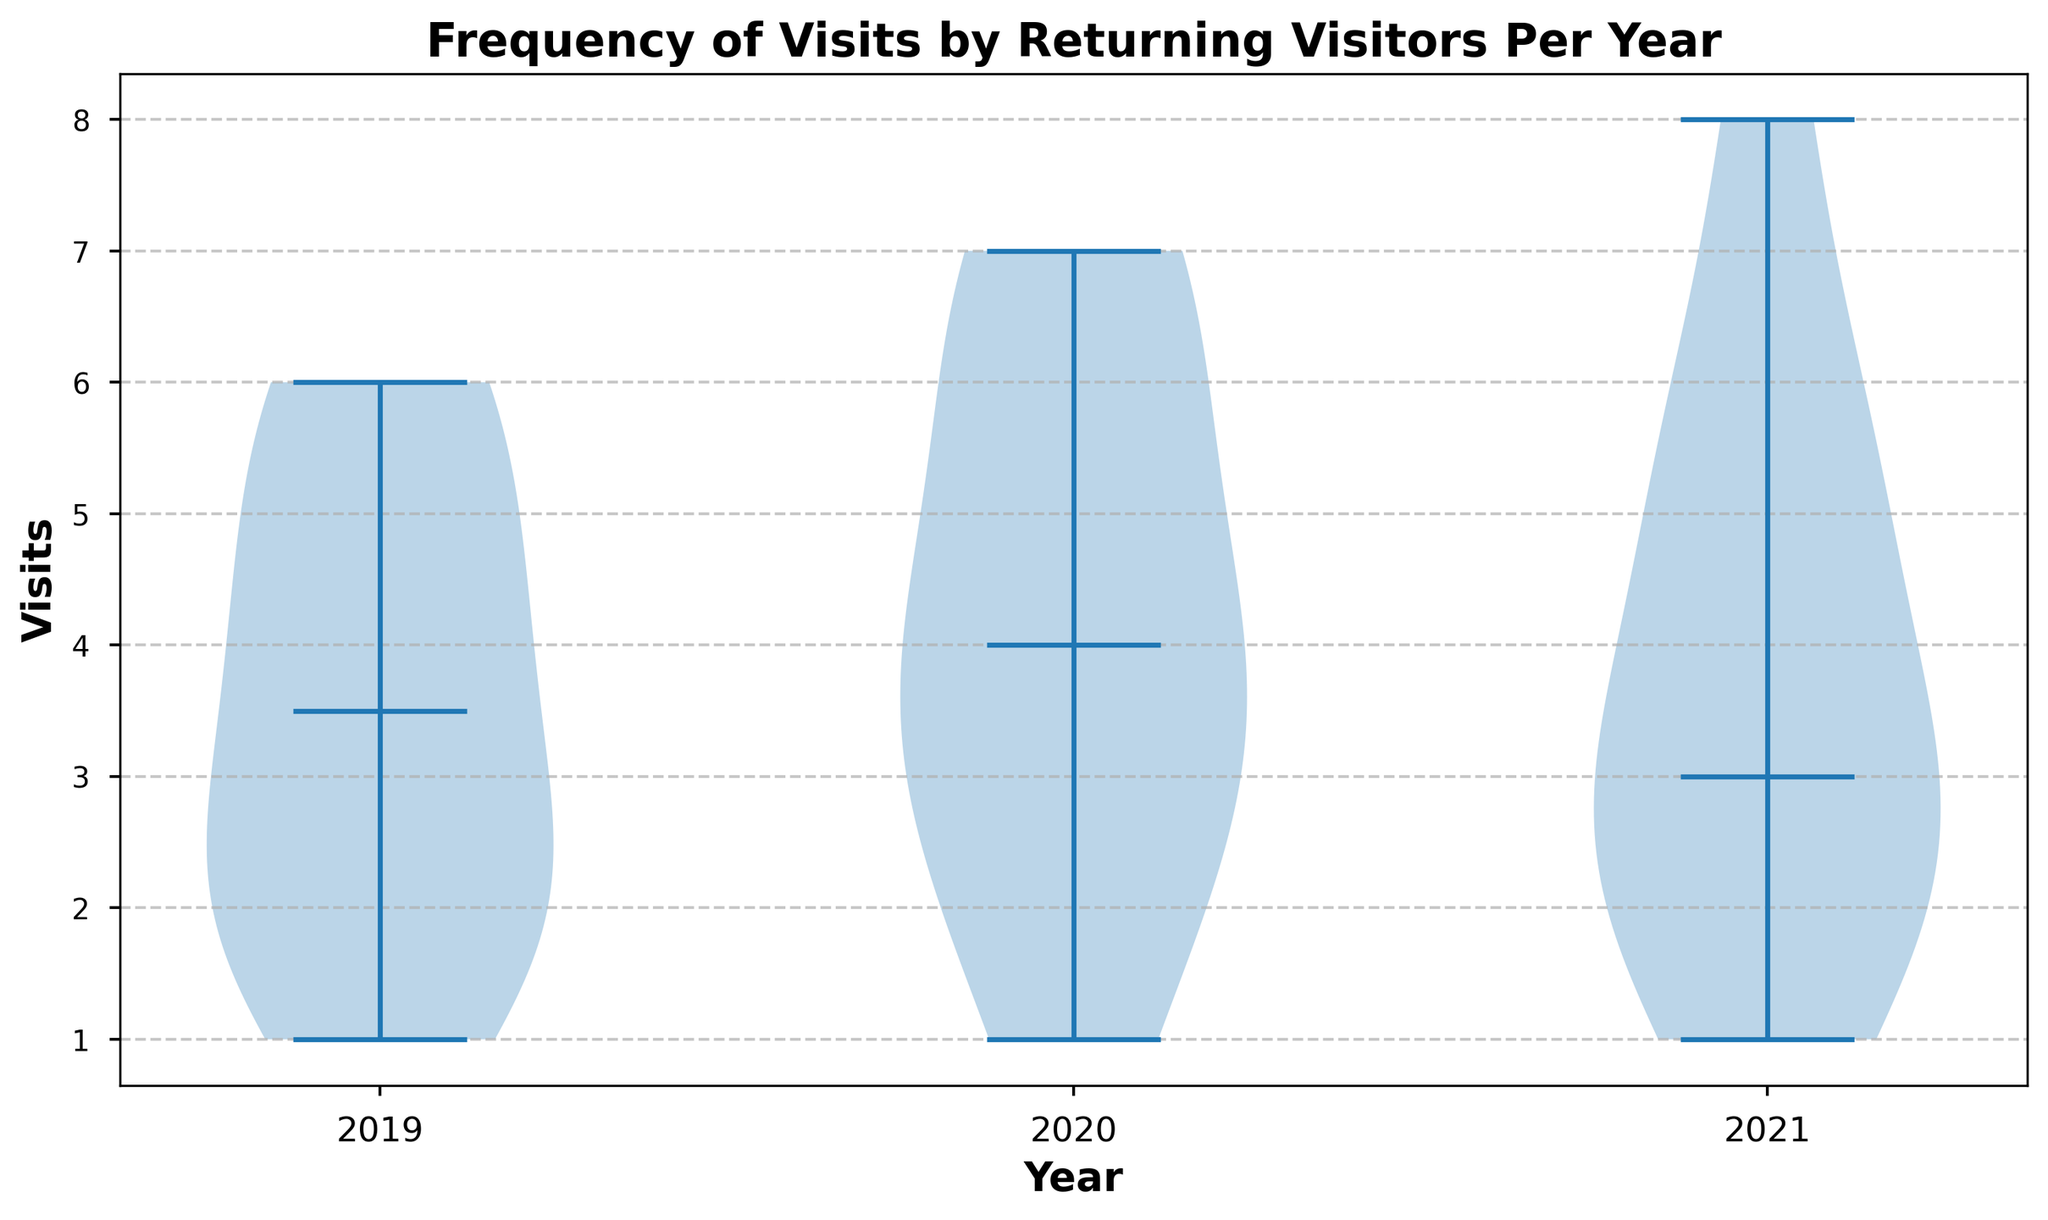How has the median number of visits per year changed from 2019 to 2021? By observing the position of the median markers on the violin plot for each year, we can compare their vertical positions to determine how the median number of visits has changed over the years.
Answer: The median number of visits is consistent across 2019, 2020, and 2021 Which year shows the highest variability in the number of visits? To determine the year with the highest variability, we look for the year with the widest spread in the data within the violin plot. The more spread out the 'violin' shape is, the higher the variability.
Answer: 2021 Are the median values of the number of visits different across the years? By checking the positions of the median lines within each violin plot, we observe their vertical positions and compare them directly.
Answer: No, the median values are the same across the years How does the interquartile range of visits in 2020 compare to 2019? The interquartile range (IQR) can be inferred by looking at the width of the violin plots in their central portions. A wider area around the center indicates a larger IQR. Compare this width for 2019 and 2020.
Answer: The IQR of visits in 2020 is slightly larger than in 2019 In which year do we observe the lowest visits? We need to inspect the bottom portion of each violin plot. The lowest mark on the violin plot indicates the minimum number of visits.
Answer: 2019 and 2020 both have a minimum of 1 visit Comparing the distribution shapes, which year has the most uniform distribution of visits? A uniform distribution would appear as a thick, evenly distributed shape without large increases or decreases in width. Analyze the shapes in each year's violin plot.
Answer: 2020 What can you say about the skewness of visits each year? Skewness refers to the asymmetry of the distribution. By observing whether the bulk of the data in each violin plot is above or below the median line, we can infer the direction of skewness for each year.
Answer: 2019 and 2020 are slightly negative skewed, 2021 is positively skewed Which years have similar central tendencies in terms of visit frequency? Central tendencies refer to median (middle value). Identify the years where the median markers align horizontally, indicating similar medians.
Answer: All years (2019, 2020, 2021 have similar central tendencies) 